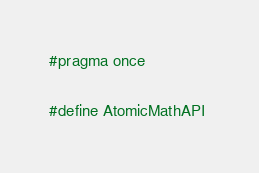Convert code to text. <code><loc_0><loc_0><loc_500><loc_500><_C_>#pragma once

#define AtomicMathAPI </code> 